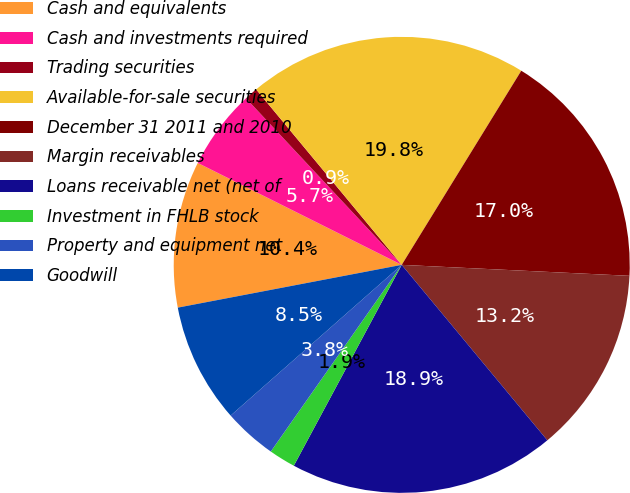Convert chart to OTSL. <chart><loc_0><loc_0><loc_500><loc_500><pie_chart><fcel>Cash and equivalents<fcel>Cash and investments required<fcel>Trading securities<fcel>Available-for-sale securities<fcel>December 31 2011 and 2010<fcel>Margin receivables<fcel>Loans receivable net (net of<fcel>Investment in FHLB stock<fcel>Property and equipment net<fcel>Goodwill<nl><fcel>10.38%<fcel>5.66%<fcel>0.94%<fcel>19.81%<fcel>16.98%<fcel>13.21%<fcel>18.87%<fcel>1.89%<fcel>3.77%<fcel>8.49%<nl></chart> 